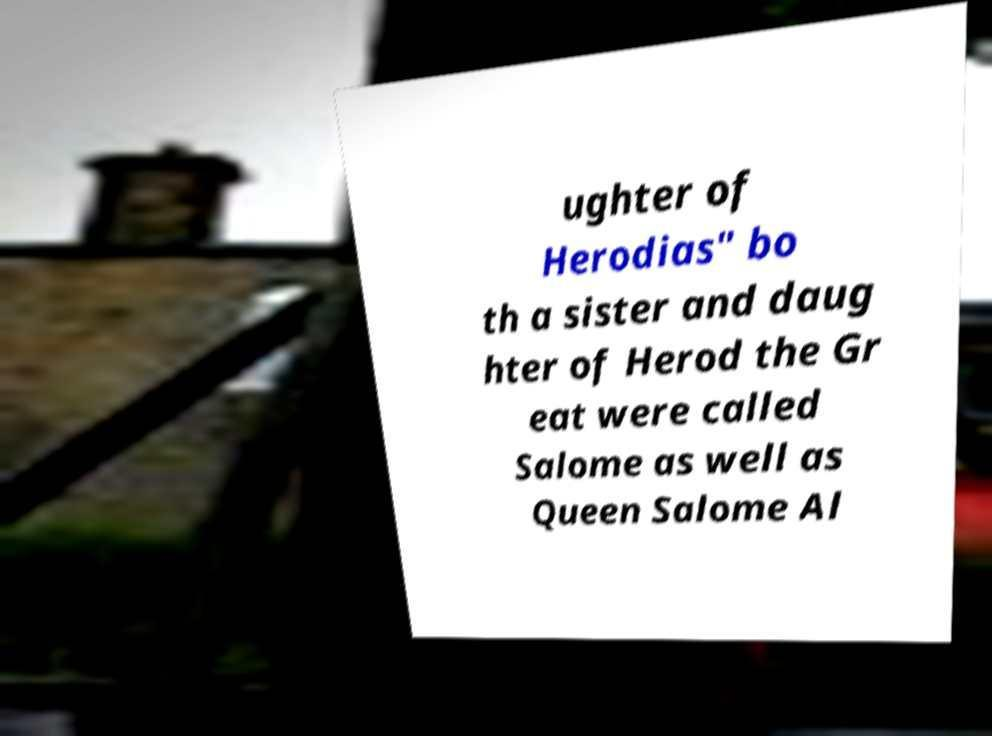There's text embedded in this image that I need extracted. Can you transcribe it verbatim? ughter of Herodias" bo th a sister and daug hter of Herod the Gr eat were called Salome as well as Queen Salome Al 